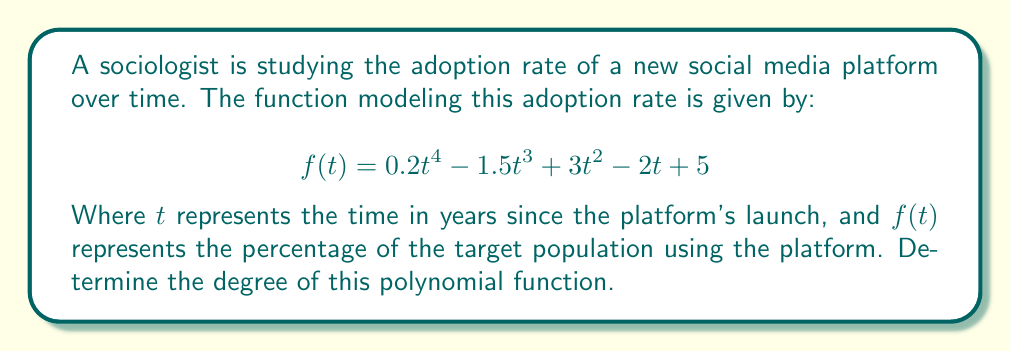Can you answer this question? To determine the degree of a polynomial function, we need to identify the highest power of the variable in the function. Let's examine each term of the given function:

1. $0.2t^4$: The exponent of $t$ is 4
2. $-1.5t^3$: The exponent of $t$ is 3
3. $3t^2$: The exponent of $t$ is 2
4. $-2t$: The exponent of $t$ is 1 (often omitted in writing)
5. $5$: This is a constant term, equivalent to $t^0$

The highest exponent among all terms is 4, which appears in the first term $0.2t^4$. 

Therefore, the degree of this polynomial function is 4.

This degree indicates that the adoption rate of the new social media platform is modeled by a quartic function, which can capture more complex patterns of technology adoption compared to simpler linear or quadratic models. This aligns with the sociologist's argument that traditional communication theories (which often use simpler models) can be adapted and remain relevant in the digital age by incorporating more sophisticated mathematical representations.
Answer: 4 